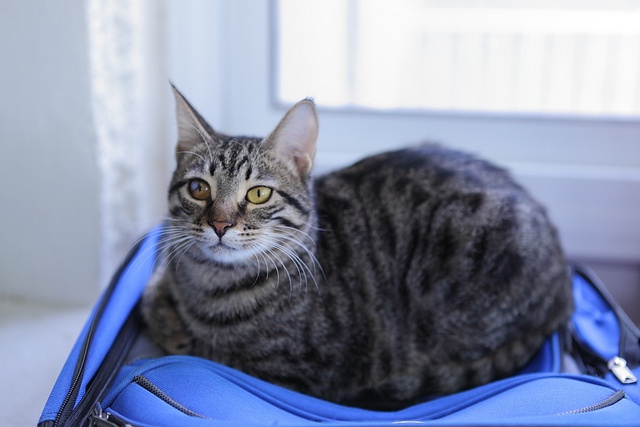Describe the objects in this image and their specific colors. I can see cat in darkgray, black, and gray tones and suitcase in darkgray, lightblue, blue, and navy tones in this image. 